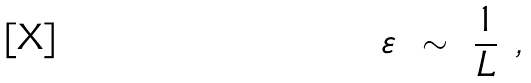Convert formula to latex. <formula><loc_0><loc_0><loc_500><loc_500>\varepsilon \ \sim \ \frac { 1 } { L } \ ,</formula> 